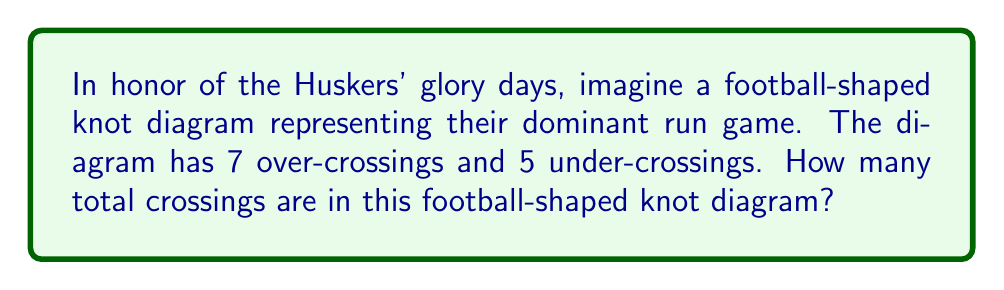What is the answer to this math problem? Let's break this down step-by-step:

1) In knot theory, a crossing in a knot diagram is a point where the knot passes over or under itself.

2) Each crossing in a knot diagram can be classified as either an over-crossing or an under-crossing, depending on which strand is on top at that point.

3) In this football-shaped knot diagram:
   - We have 7 over-crossings
   - We have 5 under-crossings

4) To find the total number of crossings, we simply need to add the number of over-crossings and under-crossings:

   $$\text{Total crossings} = \text{Over-crossings} + \text{Under-crossings}$$

5) Substituting the given values:

   $$\text{Total crossings} = 7 + 5 = 12$$

Therefore, the football-shaped knot diagram has a total of 12 crossings.
Answer: 12 